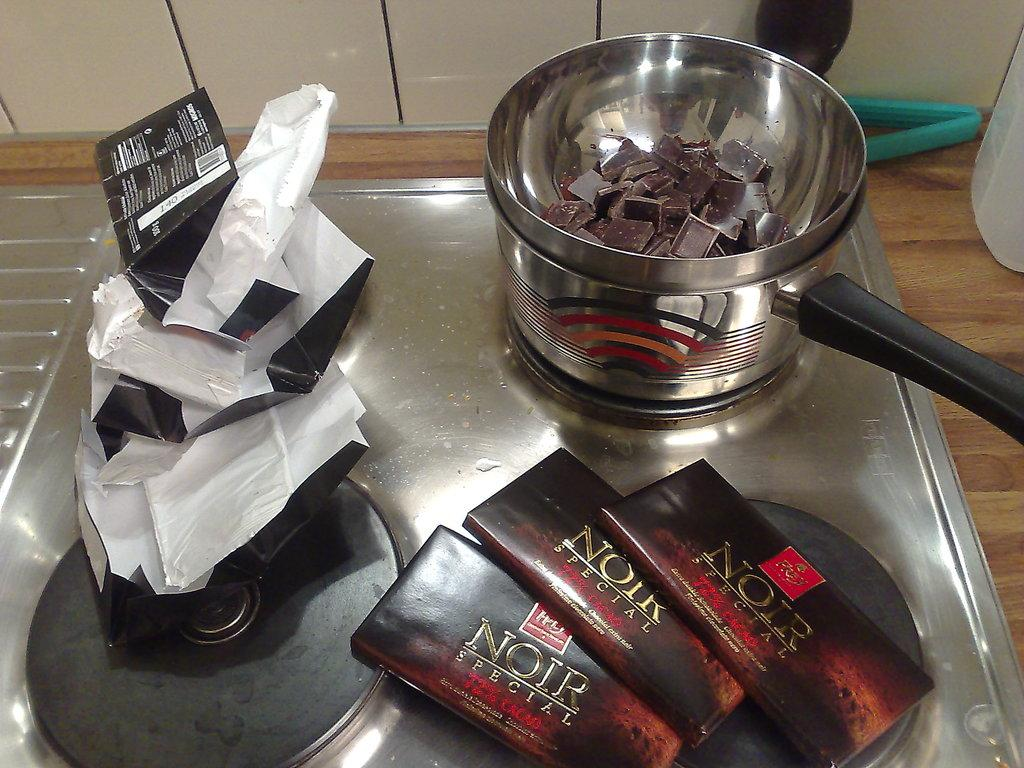<image>
Give a short and clear explanation of the subsequent image. Someone one is using Noir special chocolate and is melting it in the pot. 